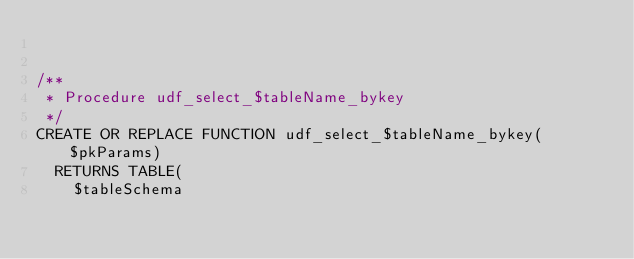<code> <loc_0><loc_0><loc_500><loc_500><_SQL_>

/**
 * Procedure udf_select_$tableName_bykey
 */
CREATE OR REPLACE FUNCTION udf_select_$tableName_bykey($pkParams)
  RETURNS TABLE(
    $tableSchema</code> 